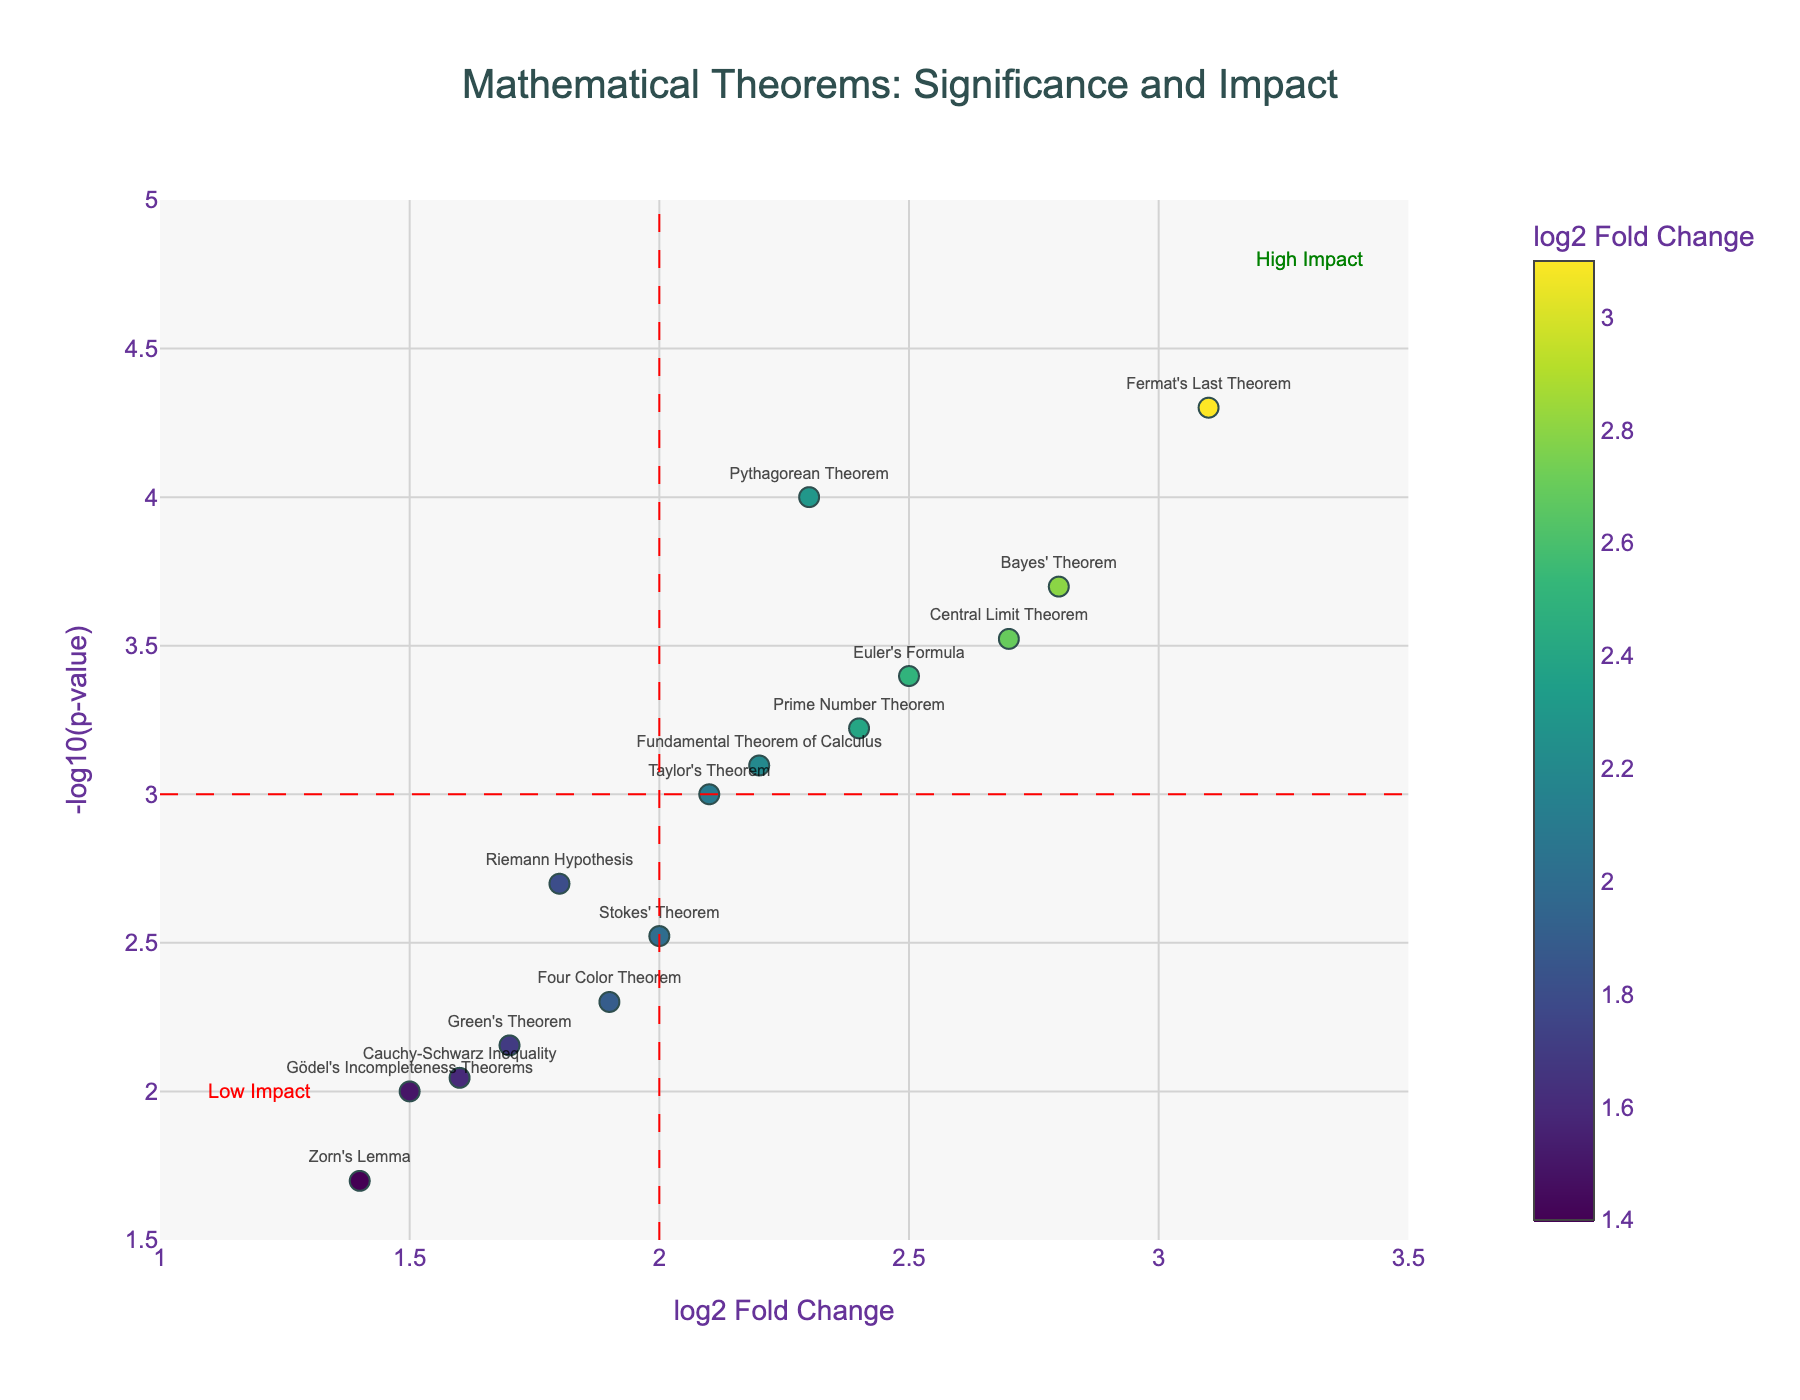What's the title of the plot? The title of the plot is prominently displayed at the top center of the figure.
Answer: Mathematical Theorems: Significance and Impact How many theorems have a log2 fold change greater than 2.5? We need to count the data points where the log2 fold change is greater than 2.5. By checking the data, the theorems are Fermat's Last Theorem (3.1), Central Limit Theorem (2.7), Bayes' Theorem (2.8).
Answer: 3 Which theorem has the highest log2 fold change? By comparing the log2 fold change values, the highest value is 3.1, corresponding to Fermat's Last Theorem.
Answer: Fermat's Last Theorem Which theorem has the highest statistical significance? The statistical significance is represented by -log10(p-value). The highest -log10(p-value) is 4.3 which corresponds to p_value 0.00005 for Fermat's Last Theorem.
Answer: Fermat's Last Theorem How many theorems have a p-value less than 0.001? We need to count the data points where p-value < 0.001. These theorems are Pythagorean Theorem, Fermat's Last Theorem, Central Limit Theorem, Euler's Formula, Bayes' Theorem, Prime Number Theorem.
Answer: 6 Which theorems fall in the "High Impact" region? The "High Impact" region is marked on the top right with log2 fold change > 2 and -log10(p-value) > 3. The theorems in this region are Fermat's Last Theorem, Central Limit Theorem, Euler's Formula, Bayes' Theorem.
Answer: Fermat's Last Theorem, Central Limit Theorem, Euler's Formula, Bayes' Theorem What is the log2 fold change and p-value of Green's Theorem? By looking at the hover information or the data, Green's Theorem has a log2 fold change of 1.7 and a p-value of 0.007.
Answer: log2 FC: 1.7, p-value: 0.007 Are any theorems in the "Low Impact" region? The "Low Impact" region is marked on the bottom left with log2 fold change < 2 and -log10(p-value) < 3. Theorems here include Zorn's Lemma, Gödel's Incompleteness Theorems, and Cauchy-Schwarz Inequality.
Answer: Zorn's Lemma, Gödel's Incompleteness Theorems, Cauchy-Schwarz Inequality What is the general trend between log2 fold change and -log10(p-value)? Observing the plot, as the log2 fold change increases, the -log10(p-value) also tends to increase, indicating a positive correlation between impact and statistical significance.
Answer: Positive correlation 